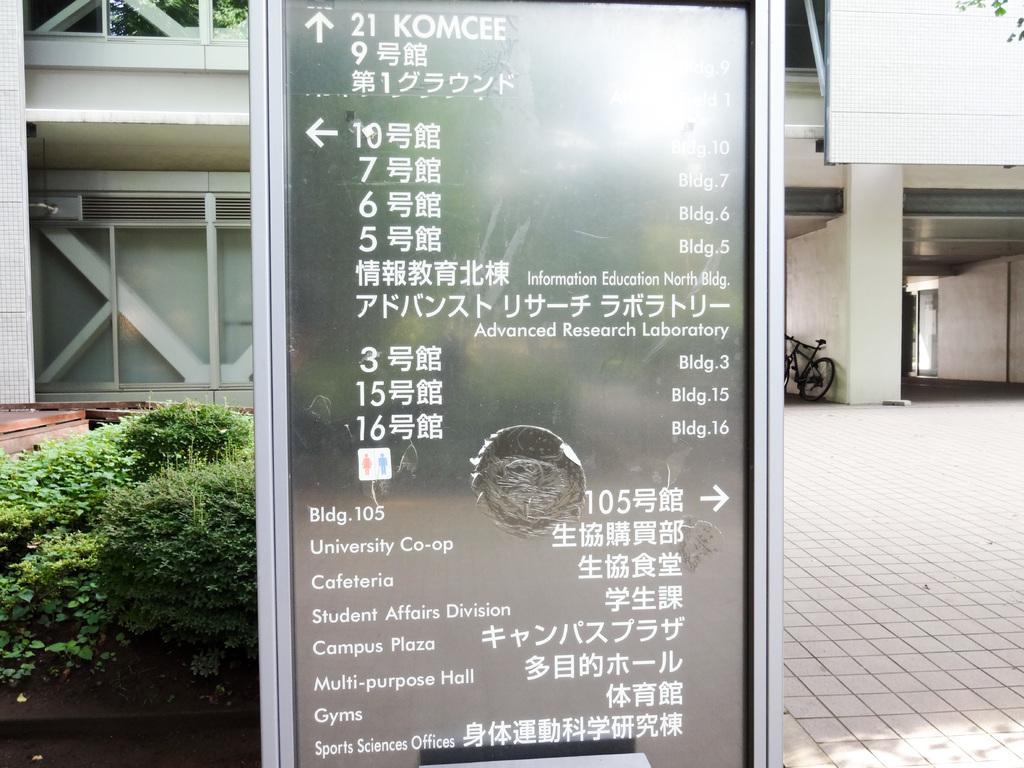In one or two sentences, can you explain what this image depicts? In the image in the center, we can see one sign board and we can see something written on it. In the background there is a building, wall, door, cycle and plants. 